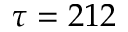<formula> <loc_0><loc_0><loc_500><loc_500>\tau = 2 1 2</formula> 